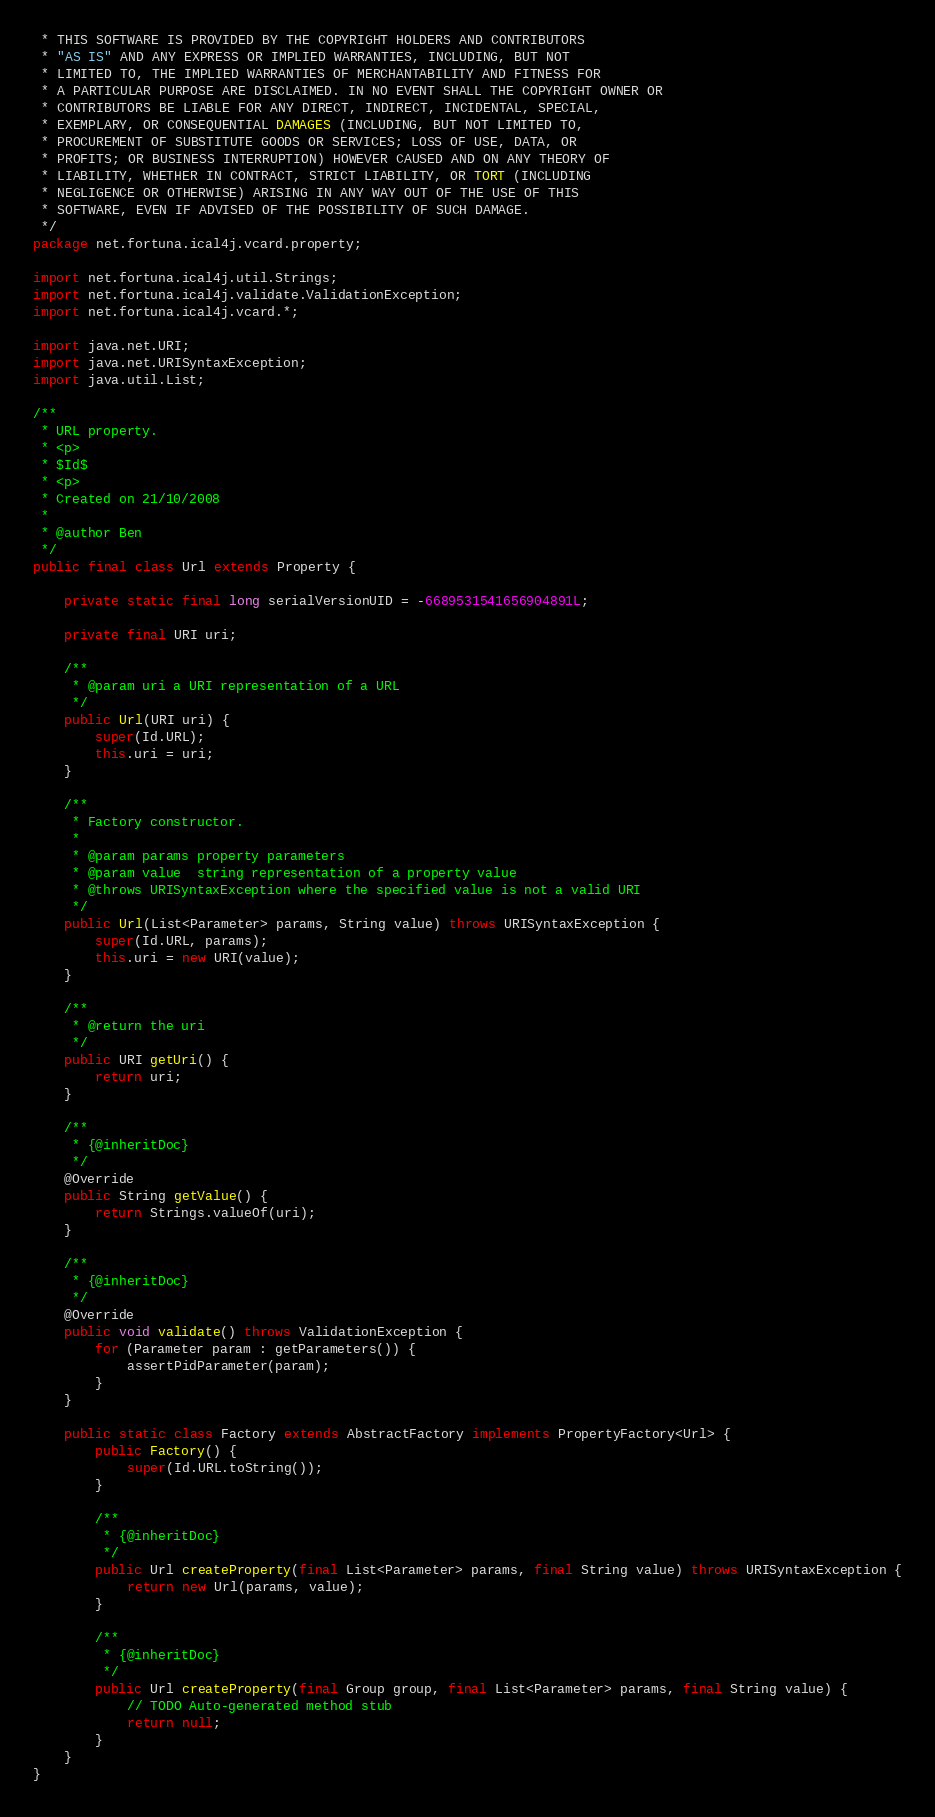Convert code to text. <code><loc_0><loc_0><loc_500><loc_500><_Java_> * THIS SOFTWARE IS PROVIDED BY THE COPYRIGHT HOLDERS AND CONTRIBUTORS
 * "AS IS" AND ANY EXPRESS OR IMPLIED WARRANTIES, INCLUDING, BUT NOT
 * LIMITED TO, THE IMPLIED WARRANTIES OF MERCHANTABILITY AND FITNESS FOR
 * A PARTICULAR PURPOSE ARE DISCLAIMED. IN NO EVENT SHALL THE COPYRIGHT OWNER OR
 * CONTRIBUTORS BE LIABLE FOR ANY DIRECT, INDIRECT, INCIDENTAL, SPECIAL,
 * EXEMPLARY, OR CONSEQUENTIAL DAMAGES (INCLUDING, BUT NOT LIMITED TO,
 * PROCUREMENT OF SUBSTITUTE GOODS OR SERVICES; LOSS OF USE, DATA, OR
 * PROFITS; OR BUSINESS INTERRUPTION) HOWEVER CAUSED AND ON ANY THEORY OF
 * LIABILITY, WHETHER IN CONTRACT, STRICT LIABILITY, OR TORT (INCLUDING
 * NEGLIGENCE OR OTHERWISE) ARISING IN ANY WAY OUT OF THE USE OF THIS
 * SOFTWARE, EVEN IF ADVISED OF THE POSSIBILITY OF SUCH DAMAGE.
 */
package net.fortuna.ical4j.vcard.property;

import net.fortuna.ical4j.util.Strings;
import net.fortuna.ical4j.validate.ValidationException;
import net.fortuna.ical4j.vcard.*;

import java.net.URI;
import java.net.URISyntaxException;
import java.util.List;

/**
 * URL property.
 * <p>
 * $Id$
 * <p>
 * Created on 21/10/2008
 *
 * @author Ben
 */
public final class Url extends Property {

    private static final long serialVersionUID = -6689531541656904891L;

    private final URI uri;

    /**
     * @param uri a URI representation of a URL
     */
    public Url(URI uri) {
        super(Id.URL);
        this.uri = uri;
    }

    /**
     * Factory constructor.
     *
     * @param params property parameters
     * @param value  string representation of a property value
     * @throws URISyntaxException where the specified value is not a valid URI
     */
    public Url(List<Parameter> params, String value) throws URISyntaxException {
        super(Id.URL, params);
        this.uri = new URI(value);
    }

    /**
     * @return the uri
     */
    public URI getUri() {
        return uri;
    }

    /**
     * {@inheritDoc}
     */
    @Override
    public String getValue() {
        return Strings.valueOf(uri);
    }

    /**
     * {@inheritDoc}
     */
    @Override
    public void validate() throws ValidationException {
        for (Parameter param : getParameters()) {
            assertPidParameter(param);
        }
    }

    public static class Factory extends AbstractFactory implements PropertyFactory<Url> {
        public Factory() {
            super(Id.URL.toString());
        }

        /**
         * {@inheritDoc}
         */
        public Url createProperty(final List<Parameter> params, final String value) throws URISyntaxException {
            return new Url(params, value);
        }

        /**
         * {@inheritDoc}
         */
        public Url createProperty(final Group group, final List<Parameter> params, final String value) {
            // TODO Auto-generated method stub
            return null;
        }
    }
}
</code> 